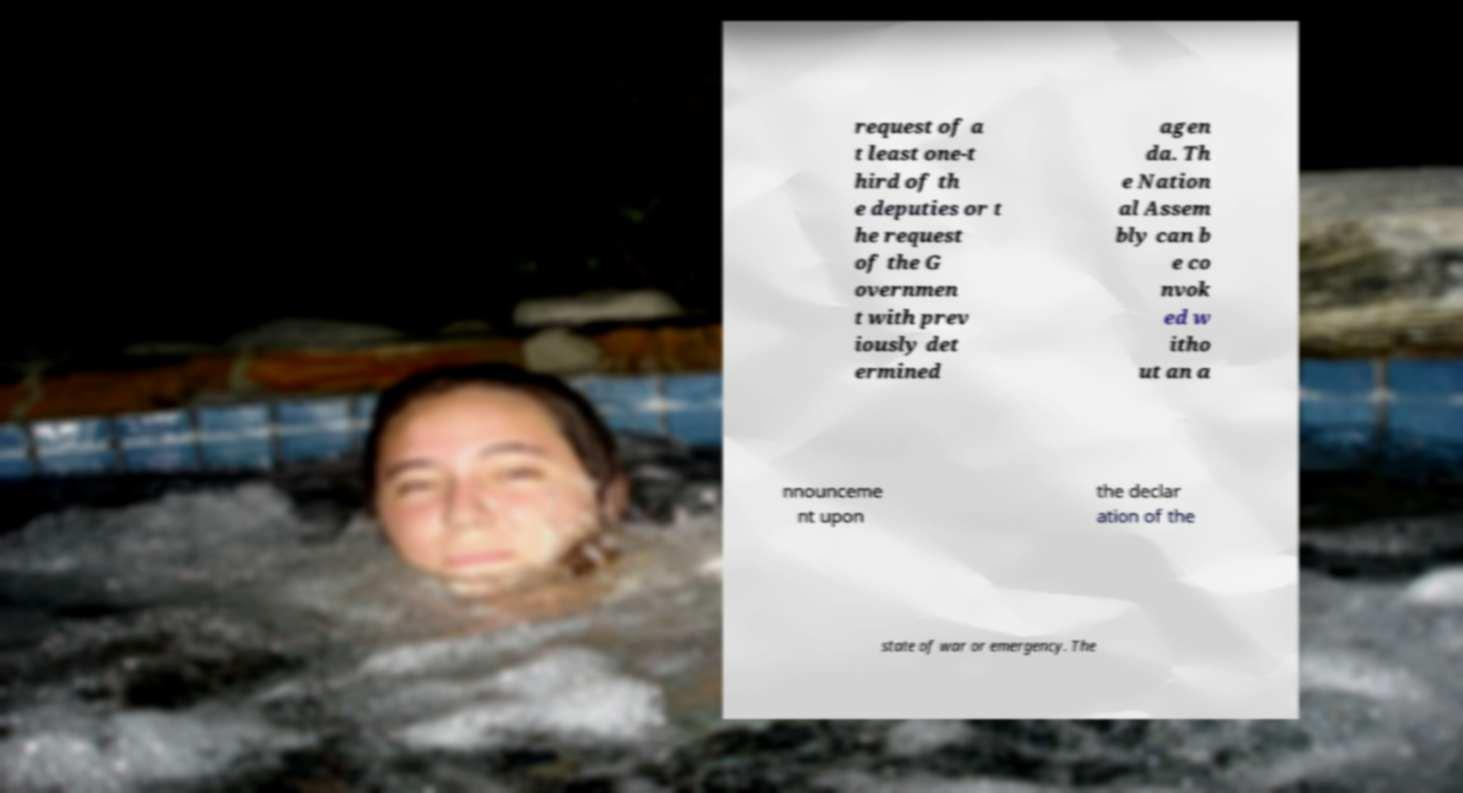Please read and relay the text visible in this image. What does it say? request of a t least one-t hird of th e deputies or t he request of the G overnmen t with prev iously det ermined agen da. Th e Nation al Assem bly can b e co nvok ed w itho ut an a nnounceme nt upon the declar ation of the state of war or emergency. The 